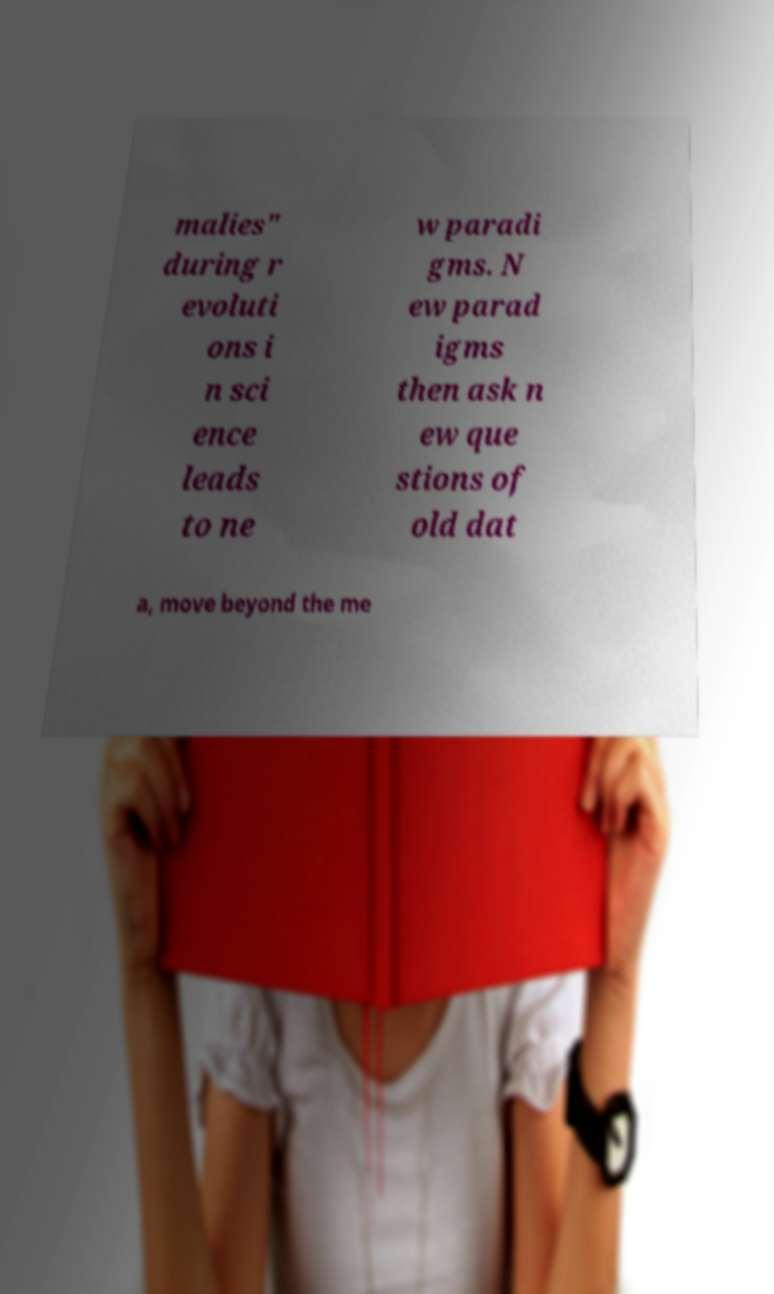Please read and relay the text visible in this image. What does it say? malies" during r evoluti ons i n sci ence leads to ne w paradi gms. N ew parad igms then ask n ew que stions of old dat a, move beyond the me 